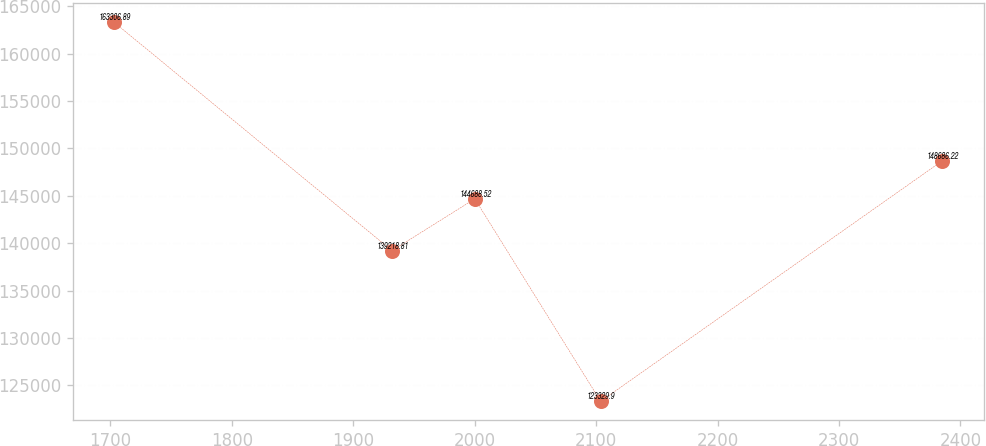<chart> <loc_0><loc_0><loc_500><loc_500><line_chart><ecel><fcel>Unnamed: 1<nl><fcel>1703.05<fcel>163307<nl><fcel>1931.85<fcel>139219<nl><fcel>2000.03<fcel>144689<nl><fcel>2103.71<fcel>123330<nl><fcel>2384.89<fcel>148686<nl></chart> 